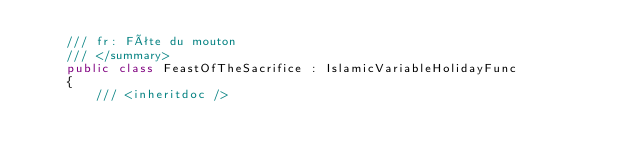<code> <loc_0><loc_0><loc_500><loc_500><_C#_>    /// fr: Fête du mouton
    /// </summary>
    public class FeastOfTheSacrifice : IslamicVariableHolidayFunc
    {
        /// <inheritdoc /></code> 